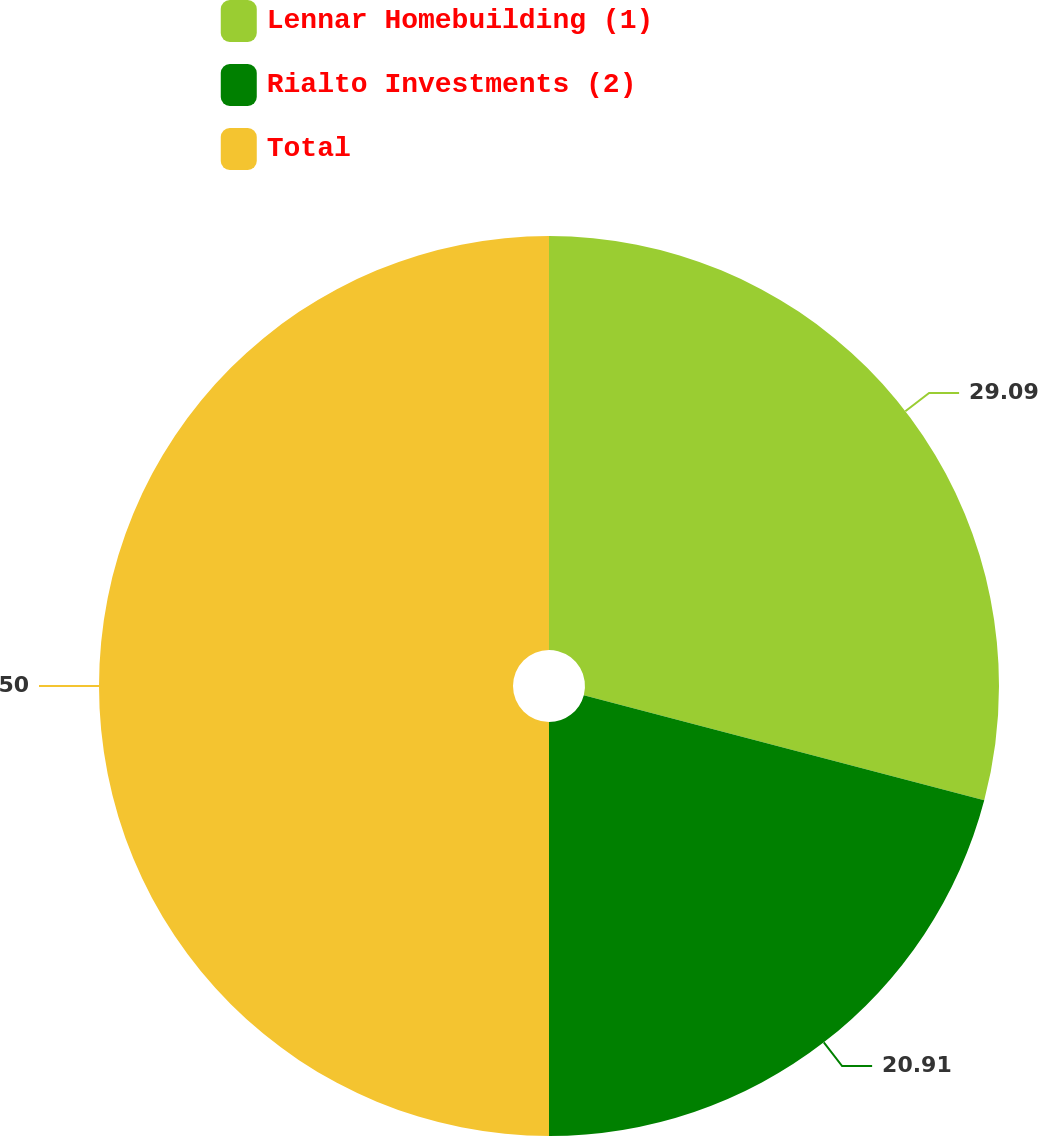Convert chart. <chart><loc_0><loc_0><loc_500><loc_500><pie_chart><fcel>Lennar Homebuilding (1)<fcel>Rialto Investments (2)<fcel>Total<nl><fcel>29.09%<fcel>20.91%<fcel>50.0%<nl></chart> 